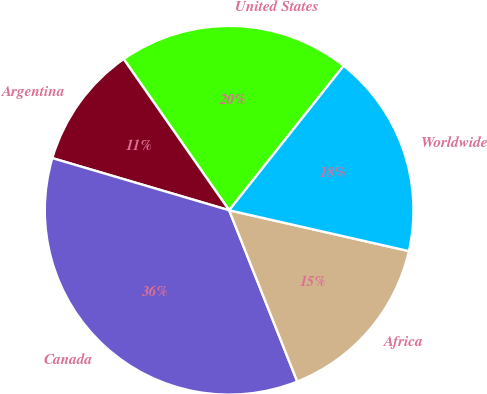<chart> <loc_0><loc_0><loc_500><loc_500><pie_chart><fcel>United States<fcel>Argentina<fcel>Canada<fcel>Africa<fcel>Worldwide<nl><fcel>20.36%<fcel>10.74%<fcel>35.59%<fcel>15.42%<fcel>17.89%<nl></chart> 